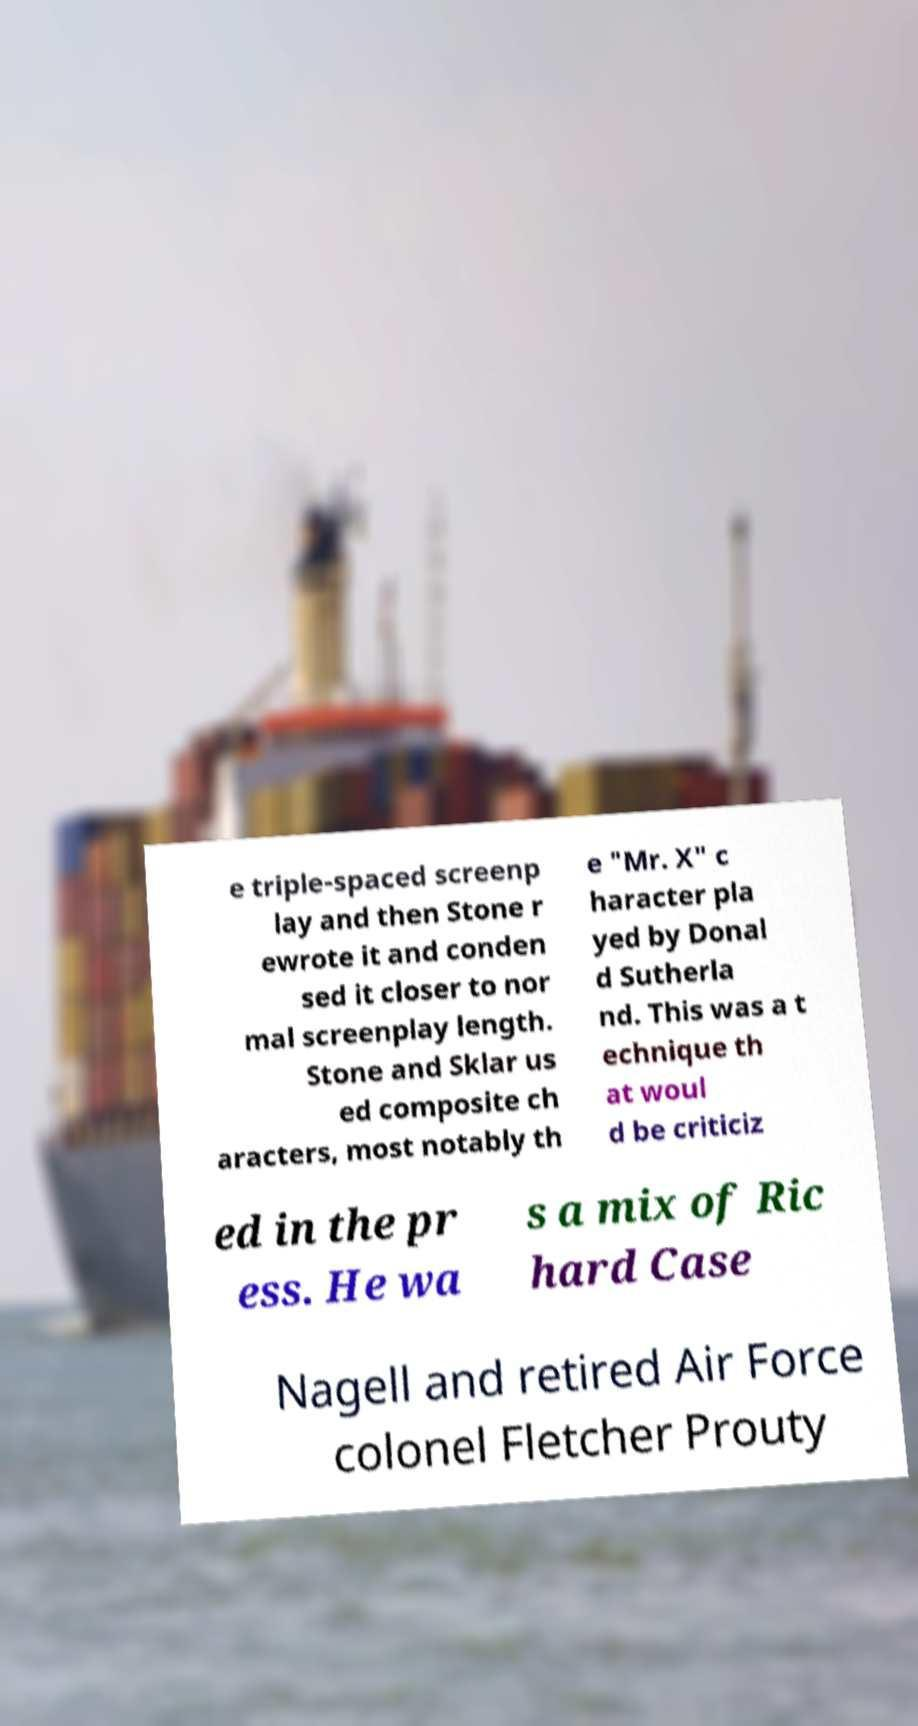Can you accurately transcribe the text from the provided image for me? e triple-spaced screenp lay and then Stone r ewrote it and conden sed it closer to nor mal screenplay length. Stone and Sklar us ed composite ch aracters, most notably th e "Mr. X" c haracter pla yed by Donal d Sutherla nd. This was a t echnique th at woul d be criticiz ed in the pr ess. He wa s a mix of Ric hard Case Nagell and retired Air Force colonel Fletcher Prouty 